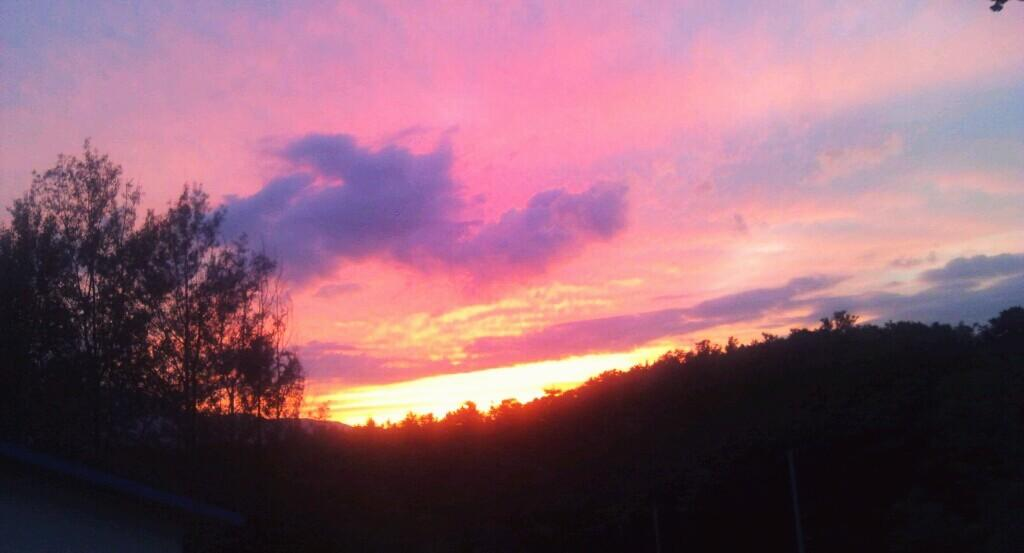What time of day is depicted in the image? The image depicts a sunset. What type of vegetation can be seen in the image? There are trees and plants in the image. What type of crack is visible in the image? There is no crack present in the image. What type of skirt can be seen on the trees in the image? There are no skirts present in the image, as trees do not wear clothing. 